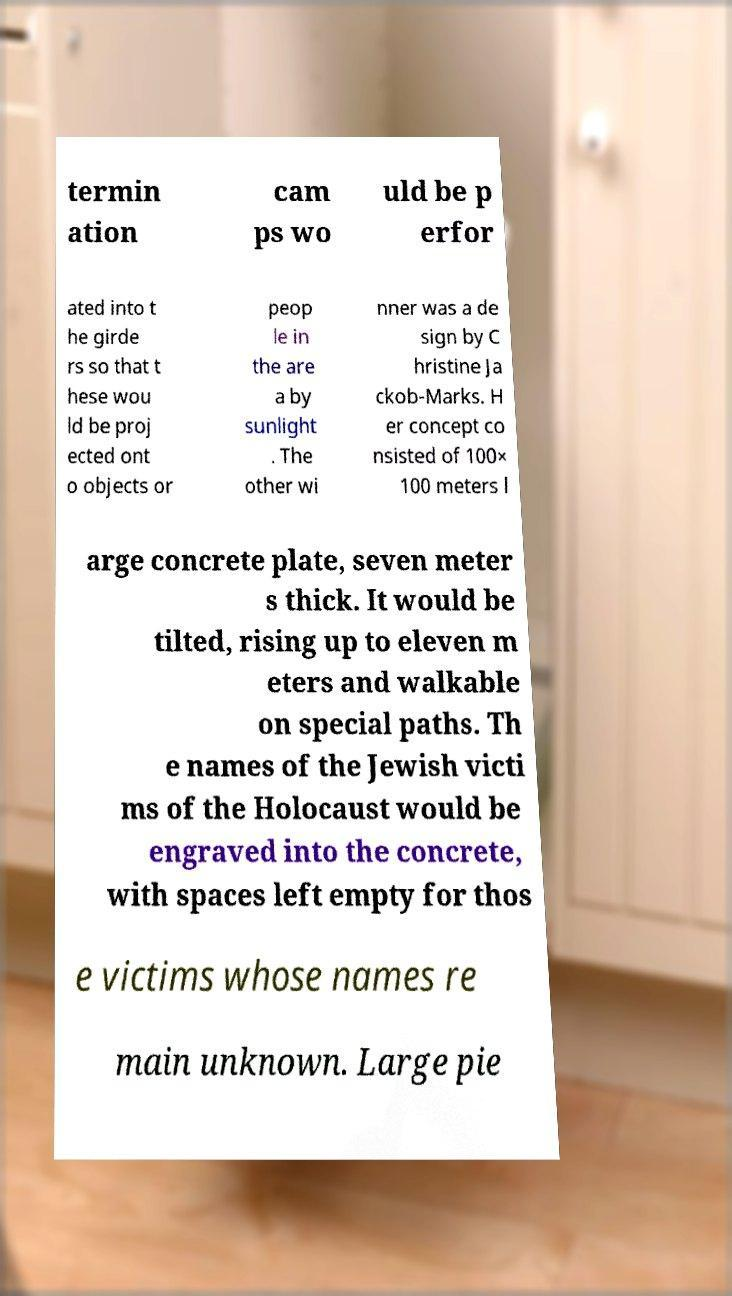Could you assist in decoding the text presented in this image and type it out clearly? termin ation cam ps wo uld be p erfor ated into t he girde rs so that t hese wou ld be proj ected ont o objects or peop le in the are a by sunlight . The other wi nner was a de sign by C hristine Ja ckob-Marks. H er concept co nsisted of 100× 100 meters l arge concrete plate, seven meter s thick. It would be tilted, rising up to eleven m eters and walkable on special paths. Th e names of the Jewish victi ms of the Holocaust would be engraved into the concrete, with spaces left empty for thos e victims whose names re main unknown. Large pie 